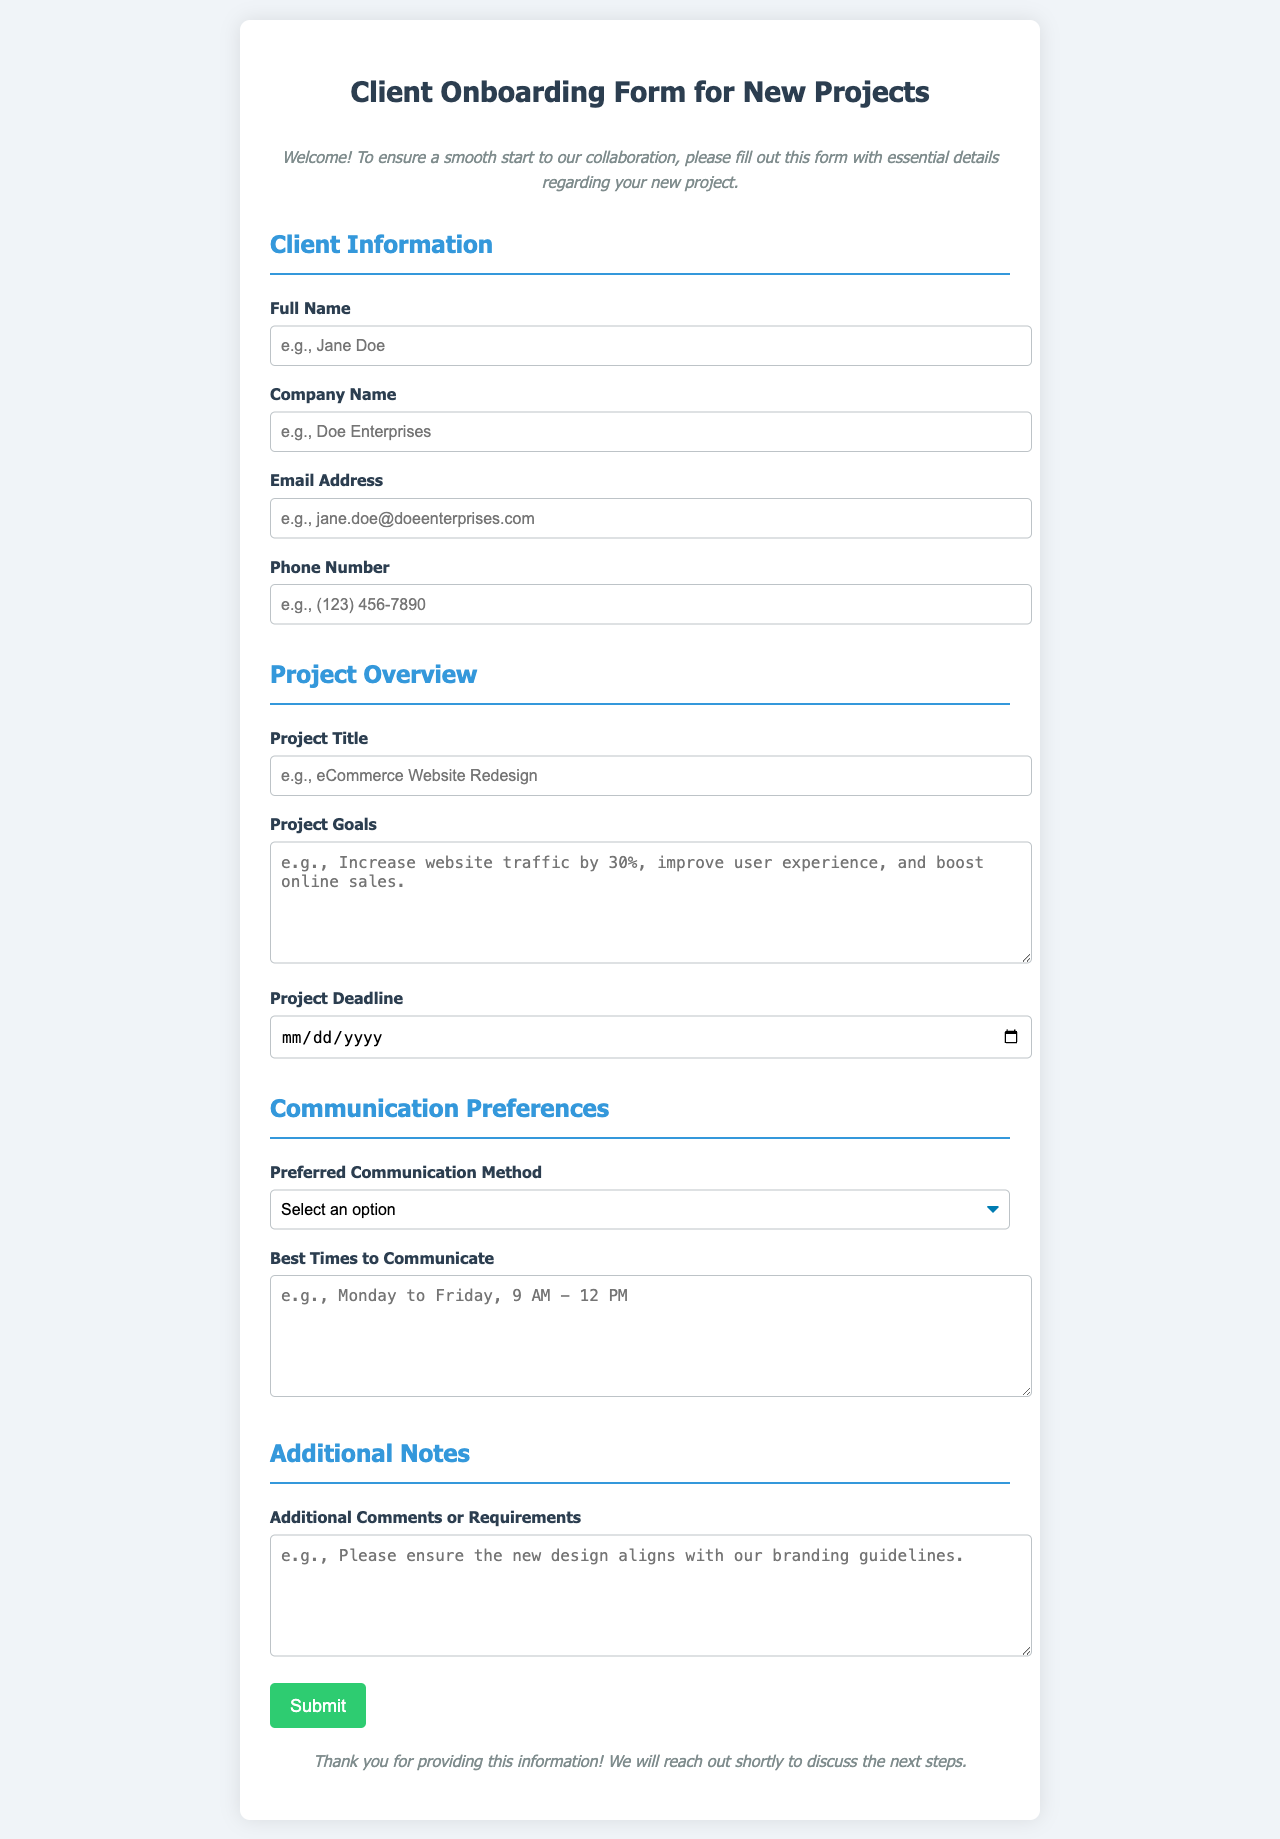what is the title of the project? The project title is specified in the "Project Title" section of the form.
Answer: Project Title who is the client? The client's name is requested in the "Full Name" field.
Answer: Full Name what is the preferred communication method? The preferred communication method is selected from the "Preferred Communication Method" dropdown menu.
Answer: Preferred Communication Method when is the project deadline? The project deadline is filled out in the "Project Deadline" input field.
Answer: Project Deadline what are the project goals? The project goals are detailed in the "Project Goals" textarea.
Answer: Project Goals how can I reach the client by phone? The client's phone number is to be provided in the "Phone Number" input field.
Answer: Phone Number what time is best for communication? The best times for communication are filled in the "Best Times to Communicate" textarea.
Answer: Best Times to Communicate what additional comments can the client provide? Additional comments or requirements are specified in the "Additional Comments or Requirements" textarea.
Answer: Additional Comments what type of document is this? This document is classified as a client onboarding form for new projects.
Answer: Client Onboarding Form 